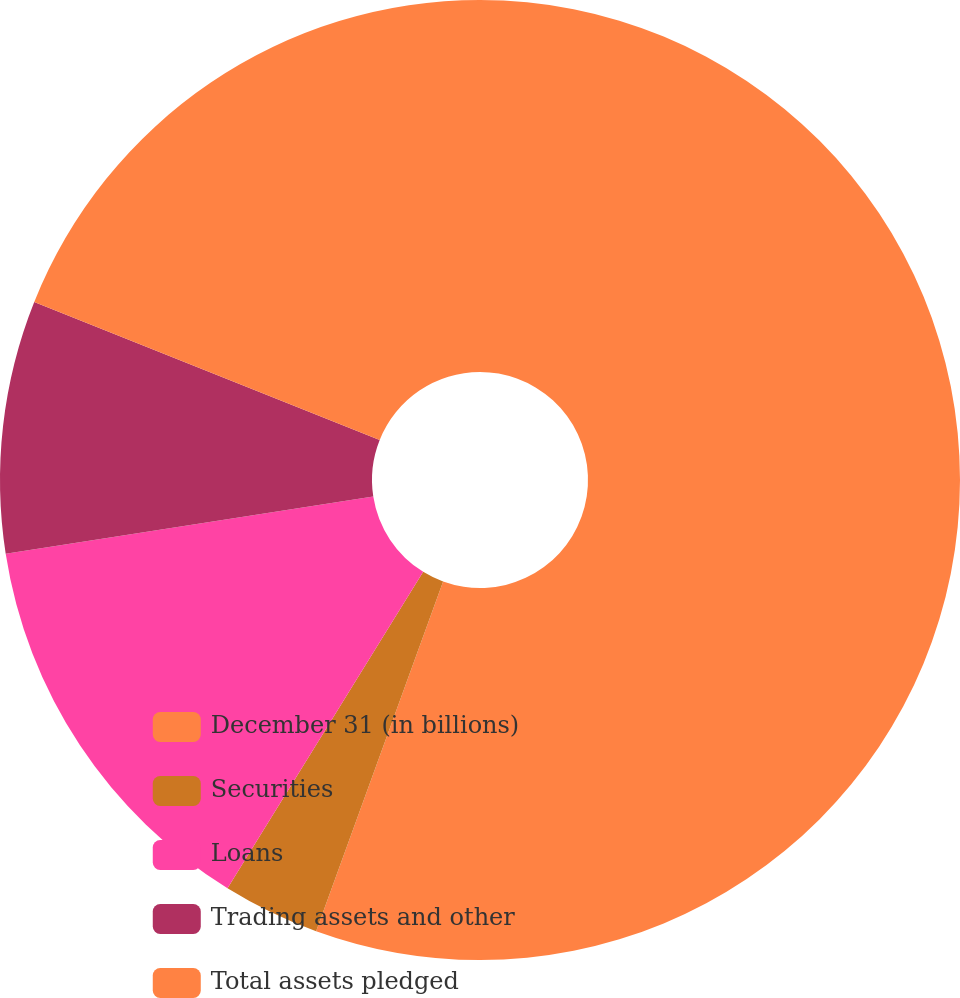<chart> <loc_0><loc_0><loc_500><loc_500><pie_chart><fcel>December 31 (in billions)<fcel>Securities<fcel>Loans<fcel>Trading assets and other<fcel>Total assets pledged<nl><fcel>55.54%<fcel>3.27%<fcel>13.73%<fcel>8.5%<fcel>18.95%<nl></chart> 